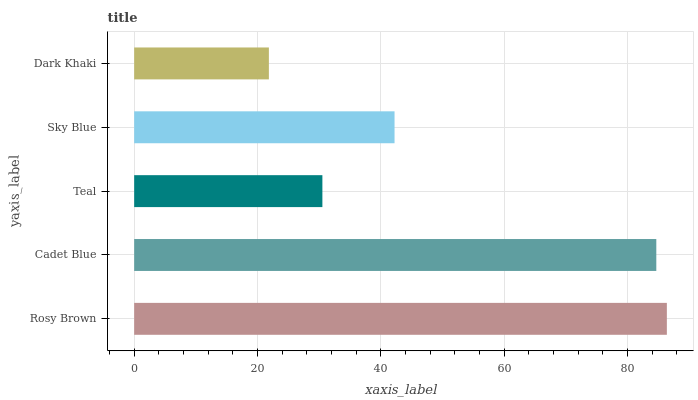Is Dark Khaki the minimum?
Answer yes or no. Yes. Is Rosy Brown the maximum?
Answer yes or no. Yes. Is Cadet Blue the minimum?
Answer yes or no. No. Is Cadet Blue the maximum?
Answer yes or no. No. Is Rosy Brown greater than Cadet Blue?
Answer yes or no. Yes. Is Cadet Blue less than Rosy Brown?
Answer yes or no. Yes. Is Cadet Blue greater than Rosy Brown?
Answer yes or no. No. Is Rosy Brown less than Cadet Blue?
Answer yes or no. No. Is Sky Blue the high median?
Answer yes or no. Yes. Is Sky Blue the low median?
Answer yes or no. Yes. Is Teal the high median?
Answer yes or no. No. Is Teal the low median?
Answer yes or no. No. 